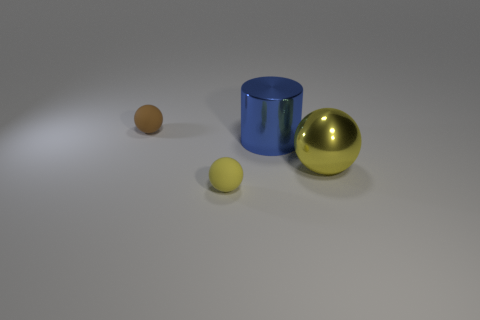What shape is the object that is both behind the large yellow ball and on the right side of the small yellow thing?
Make the answer very short. Cylinder. There is another shiny object that is the same shape as the tiny yellow object; what color is it?
Offer a terse response. Yellow. Are there any other things of the same color as the metal sphere?
Keep it short and to the point. Yes. What shape is the object that is to the left of the object in front of the big shiny object that is in front of the cylinder?
Your answer should be very brief. Sphere. There is a object that is behind the blue metal cylinder; does it have the same size as the rubber ball to the right of the small brown object?
Your answer should be very brief. Yes. How many large yellow balls are the same material as the small yellow sphere?
Ensure brevity in your answer.  0. What number of metal cylinders are right of the big thing on the left side of the yellow sphere that is right of the small yellow object?
Your answer should be very brief. 0. Does the big yellow object have the same shape as the tiny yellow matte thing?
Offer a very short reply. Yes. Are there any gray things of the same shape as the small brown object?
Offer a very short reply. No. There is a object that is the same size as the blue cylinder; what shape is it?
Provide a short and direct response. Sphere. 